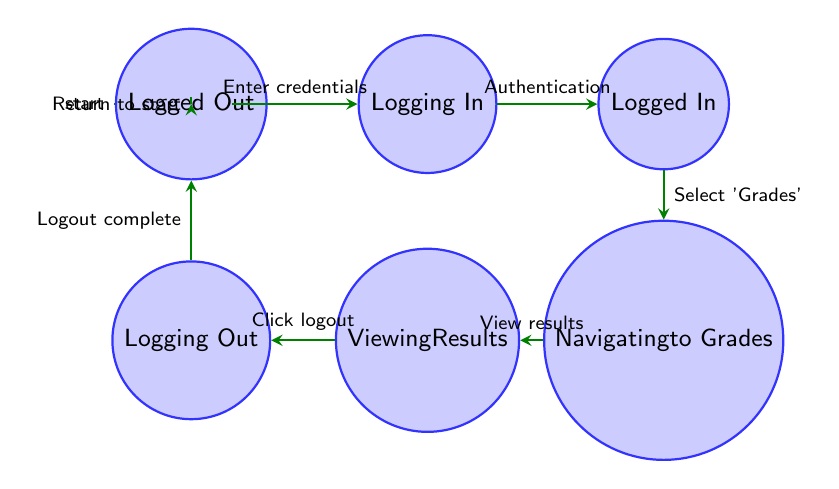What is the initial state before user interaction? The diagram displays the state named "Start" as the initial state, indicating where the user begins their journey in the process.
Answer: Start How many total states are in the diagram? The diagram lists a total of 7 distinct states: Start, Logging In, Logged In, Navigating to Grades, Viewing Results, Logging Out, and Logged Out.
Answer: 7 Which action leads from Logged In to Navigating to Grades? The transition is labeled as "Select 'Grades'" which describes the user action needed to move to the next state.
Answer: Select 'Grades' What is the final state after Logging Out? The diagram shows that after successfully logging out (Logging Out), the user reaches the state called "Logged Out."
Answer: Logged Out What action must occur to transition from Viewing Results to Logging Out? The specified action is "Click logout," indicating what the user does to initiate the logout process.
Answer: Click logout Which state comes directly after Navigating to Grades? According to the diagram, the following state after Navigating to Grades is "Viewing Results."
Answer: Viewing Results What can be inferred about the transition from Start to Logged In? The transition involves entering credentials and successfully authenticating, as described in two consecutive states, indicating the login process.
Answer: Enter credentials Which state allows users to view their exam results? The state "Viewing Results" is where users can see their exam results based on the diagram's flow and labeling.
Answer: Viewing Results What does the transition from Logged Out to Start represent? This transition indicates a return to the initial state, suggesting that the user can restart the process from the very beginning after logging out.
Answer: Return to start 